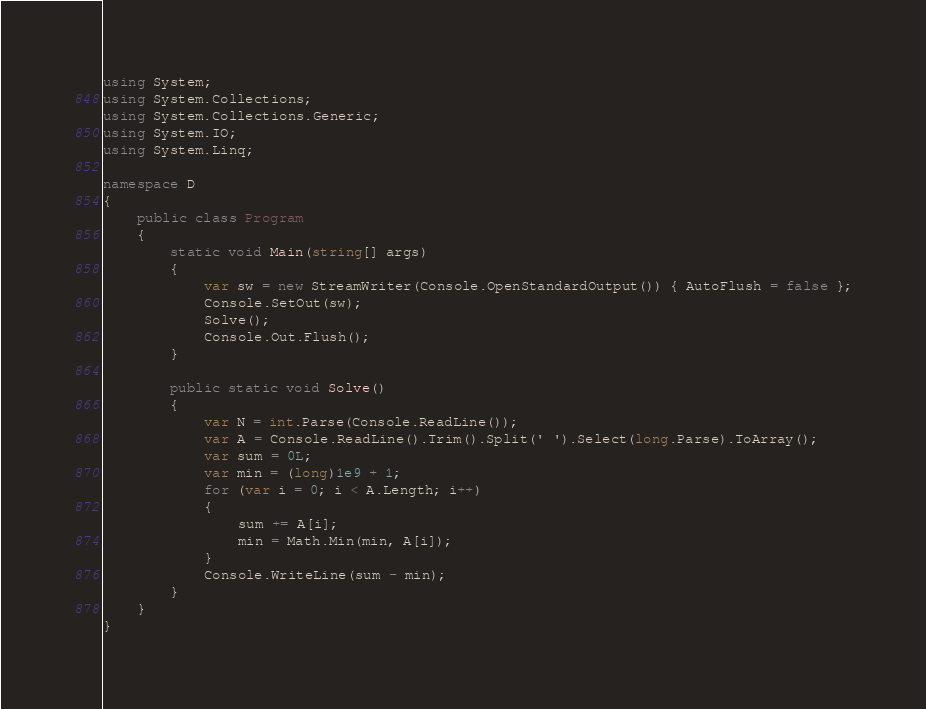Convert code to text. <code><loc_0><loc_0><loc_500><loc_500><_C#_>using System;
using System.Collections;
using System.Collections.Generic;
using System.IO;
using System.Linq;

namespace D
{
    public class Program
    {
        static void Main(string[] args)
        {
            var sw = new StreamWriter(Console.OpenStandardOutput()) { AutoFlush = false };
            Console.SetOut(sw);
            Solve();
            Console.Out.Flush();
        }

        public static void Solve()
        {
            var N = int.Parse(Console.ReadLine());
            var A = Console.ReadLine().Trim().Split(' ').Select(long.Parse).ToArray();
            var sum = 0L;
            var min = (long)1e9 + 1;
            for (var i = 0; i < A.Length; i++)
            {
                sum += A[i];
                min = Math.Min(min, A[i]);
            }
            Console.WriteLine(sum - min);
        }
    }
}
</code> 